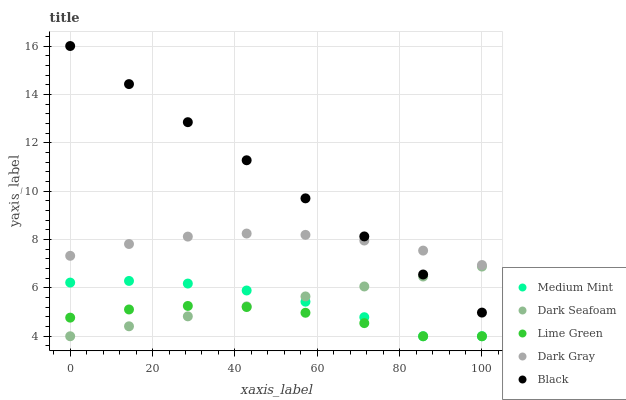Does Lime Green have the minimum area under the curve?
Answer yes or no. Yes. Does Black have the maximum area under the curve?
Answer yes or no. Yes. Does Dark Gray have the minimum area under the curve?
Answer yes or no. No. Does Dark Gray have the maximum area under the curve?
Answer yes or no. No. Is Black the smoothest?
Answer yes or no. Yes. Is Medium Mint the roughest?
Answer yes or no. Yes. Is Dark Gray the smoothest?
Answer yes or no. No. Is Dark Gray the roughest?
Answer yes or no. No. Does Medium Mint have the lowest value?
Answer yes or no. Yes. Does Dark Gray have the lowest value?
Answer yes or no. No. Does Black have the highest value?
Answer yes or no. Yes. Does Dark Gray have the highest value?
Answer yes or no. No. Is Medium Mint less than Dark Gray?
Answer yes or no. Yes. Is Dark Gray greater than Lime Green?
Answer yes or no. Yes. Does Dark Seafoam intersect Black?
Answer yes or no. Yes. Is Dark Seafoam less than Black?
Answer yes or no. No. Is Dark Seafoam greater than Black?
Answer yes or no. No. Does Medium Mint intersect Dark Gray?
Answer yes or no. No. 